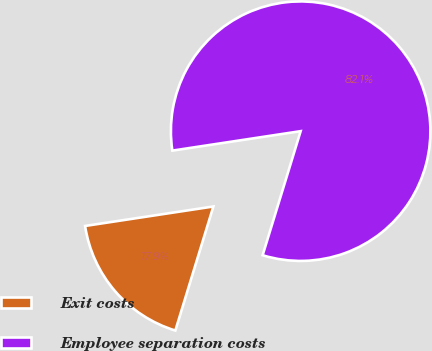<chart> <loc_0><loc_0><loc_500><loc_500><pie_chart><fcel>Exit costs<fcel>Employee separation costs<nl><fcel>17.87%<fcel>82.13%<nl></chart> 